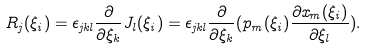Convert formula to latex. <formula><loc_0><loc_0><loc_500><loc_500>R _ { j } ( \xi _ { i } ) = \epsilon _ { j k l } \frac { \partial } { \partial \xi _ { k } } J _ { l } ( \xi _ { i } ) = \epsilon _ { j k l } \frac { \partial } { \partial \xi _ { k } } ( p _ { m } ( \xi _ { i } ) \frac { \partial x _ { m } ( \xi _ { i } ) } { \partial \xi _ { l } } ) .</formula> 